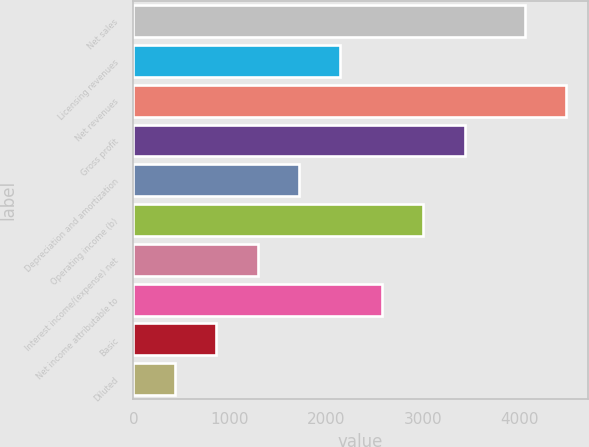<chart> <loc_0><loc_0><loc_500><loc_500><bar_chart><fcel>Net sales<fcel>Licensing revenues<fcel>Net revenues<fcel>Gross profit<fcel>Depreciation and amortization<fcel>Operating income (b)<fcel>Interest income/(expense) net<fcel>Net income attributable to<fcel>Basic<fcel>Diluted<nl><fcel>4059.1<fcel>2147.8<fcel>4488.62<fcel>3436.36<fcel>1718.28<fcel>3006.84<fcel>1288.76<fcel>2577.32<fcel>859.24<fcel>429.72<nl></chart> 